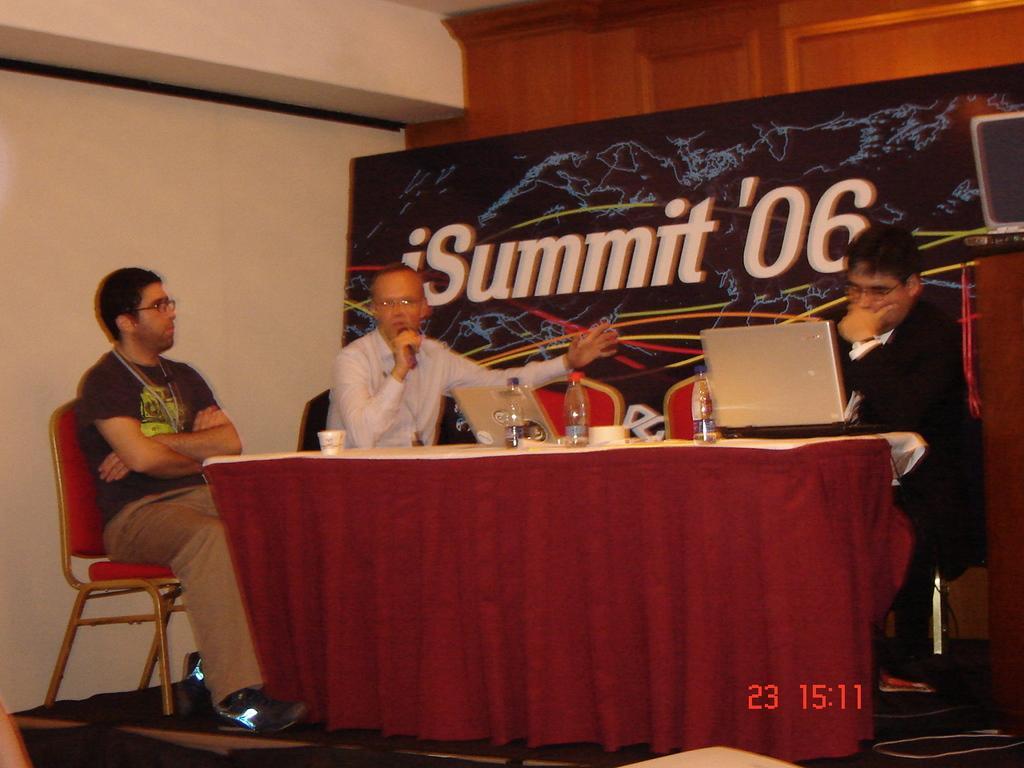Could you give a brief overview of what you see in this image? In this image there are three persons sitting on the chairs in the middle of this image is holding a Mic. There is a wall in the background. There is a poster in the middle of this image. There is a table in the bottom of this image. There are some objects kept on it. There is one laptop is kept on to this table. 